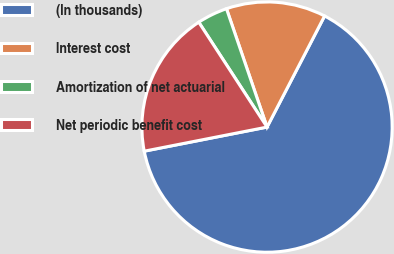Convert chart. <chart><loc_0><loc_0><loc_500><loc_500><pie_chart><fcel>(In thousands)<fcel>Interest cost<fcel>Amortization of net actuarial<fcel>Net periodic benefit cost<nl><fcel>64.31%<fcel>12.86%<fcel>3.93%<fcel>18.9%<nl></chart> 